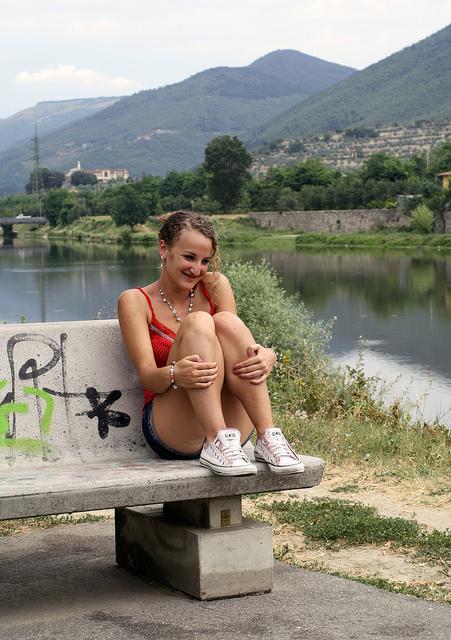What brand of sneakers is she wearing?
Short answer required. Converse. Does that look like a place to swim?
Short answer required. Yes. What is on the bench?
Answer briefly. Woman. 